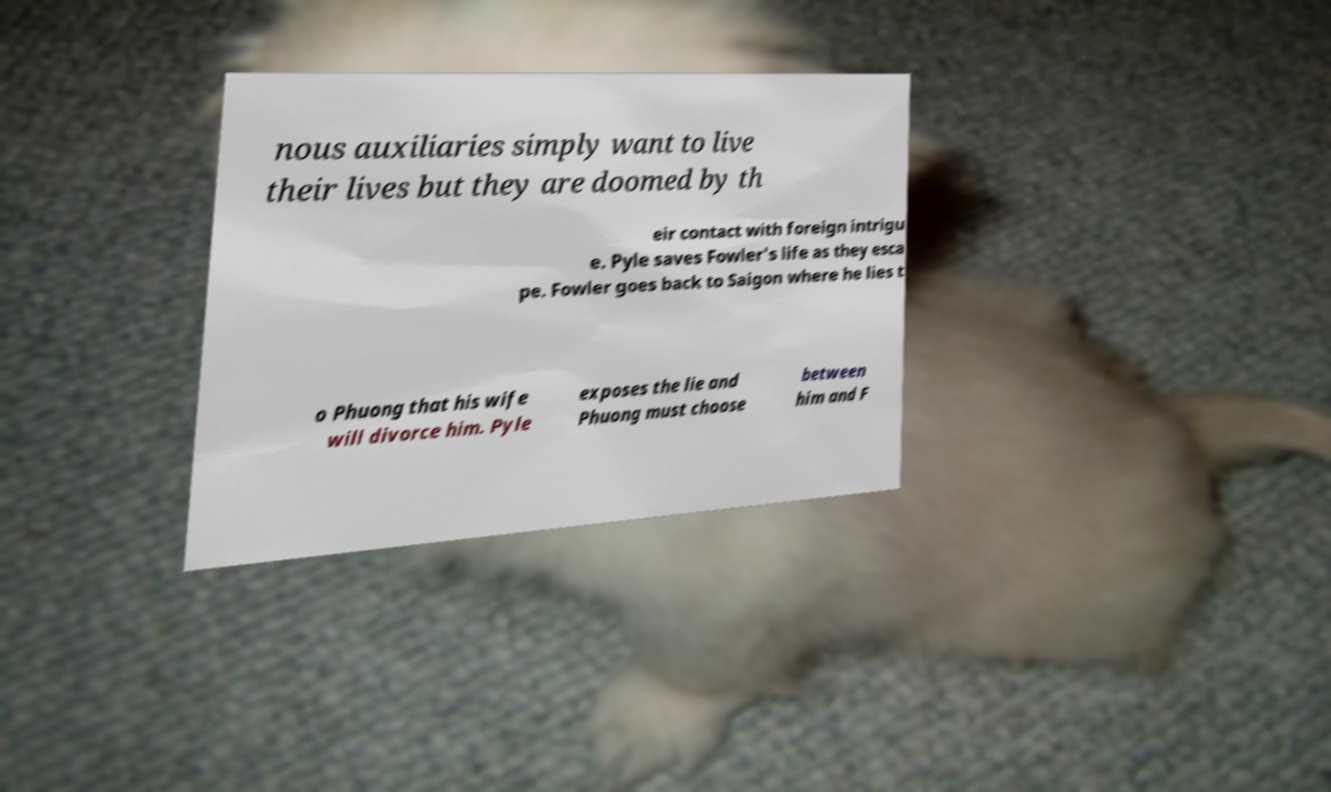Please identify and transcribe the text found in this image. nous auxiliaries simply want to live their lives but they are doomed by th eir contact with foreign intrigu e. Pyle saves Fowler's life as they esca pe. Fowler goes back to Saigon where he lies t o Phuong that his wife will divorce him. Pyle exposes the lie and Phuong must choose between him and F 